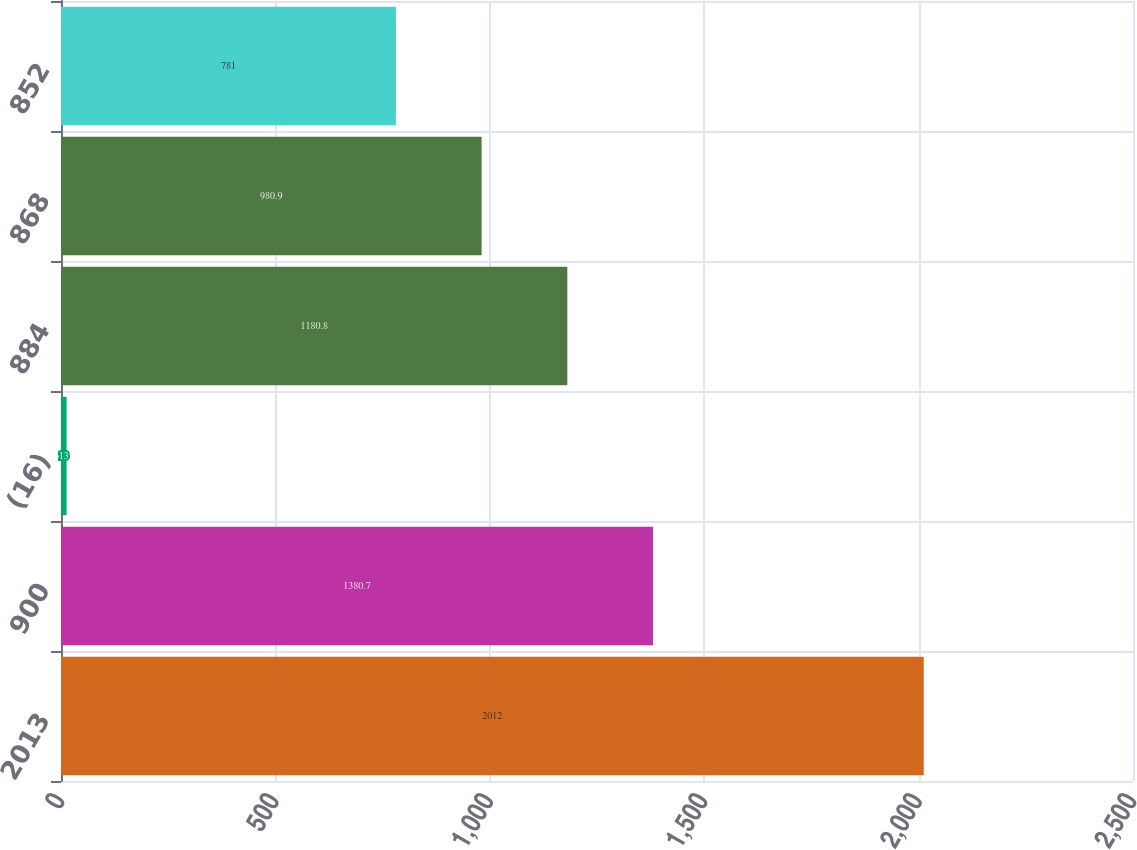Convert chart to OTSL. <chart><loc_0><loc_0><loc_500><loc_500><bar_chart><fcel>2013<fcel>900<fcel>(16)<fcel>884<fcel>868<fcel>852<nl><fcel>2012<fcel>1380.7<fcel>13<fcel>1180.8<fcel>980.9<fcel>781<nl></chart> 